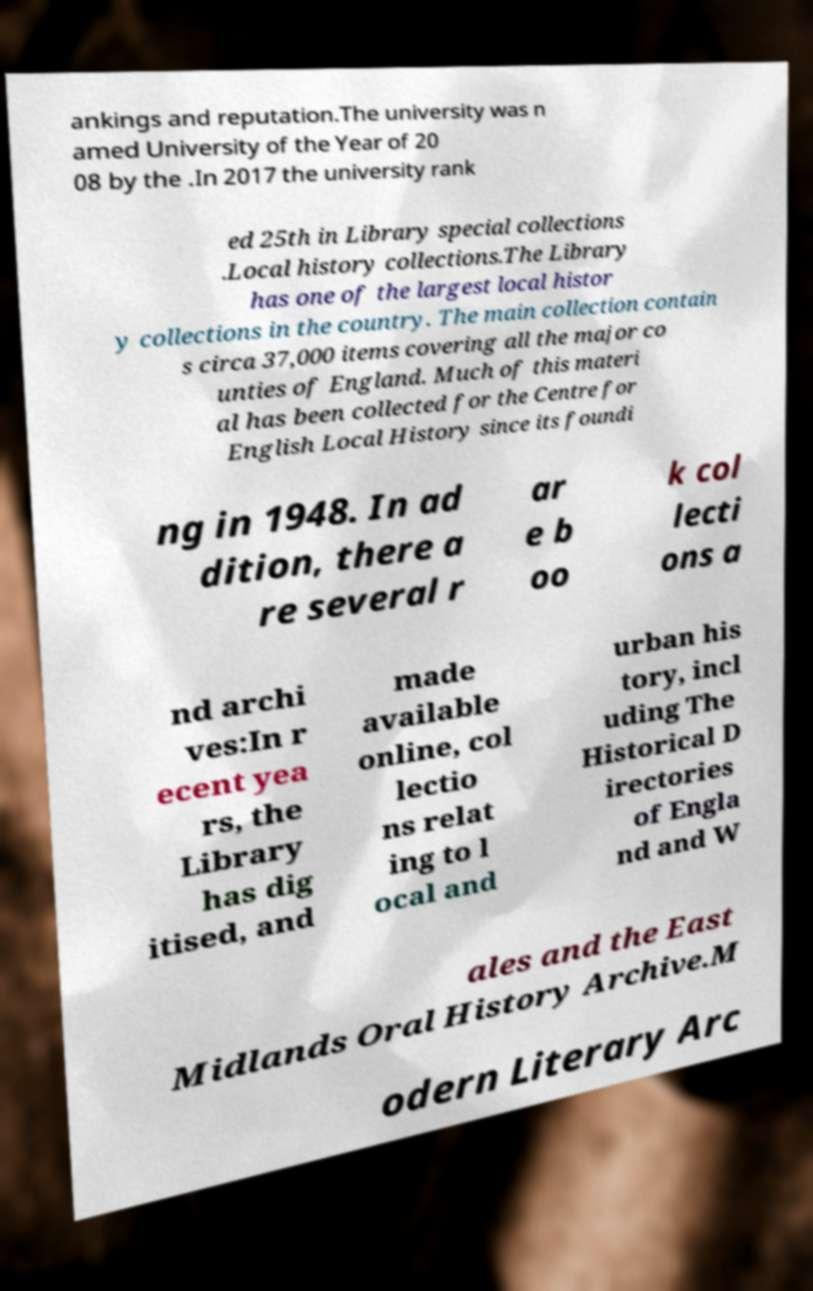Could you assist in decoding the text presented in this image and type it out clearly? ankings and reputation.The university was n amed University of the Year of 20 08 by the .In 2017 the university rank ed 25th in Library special collections .Local history collections.The Library has one of the largest local histor y collections in the country. The main collection contain s circa 37,000 items covering all the major co unties of England. Much of this materi al has been collected for the Centre for English Local History since its foundi ng in 1948. In ad dition, there a re several r ar e b oo k col lecti ons a nd archi ves:In r ecent yea rs, the Library has dig itised, and made available online, col lectio ns relat ing to l ocal and urban his tory, incl uding The Historical D irectories of Engla nd and W ales and the East Midlands Oral History Archive.M odern Literary Arc 